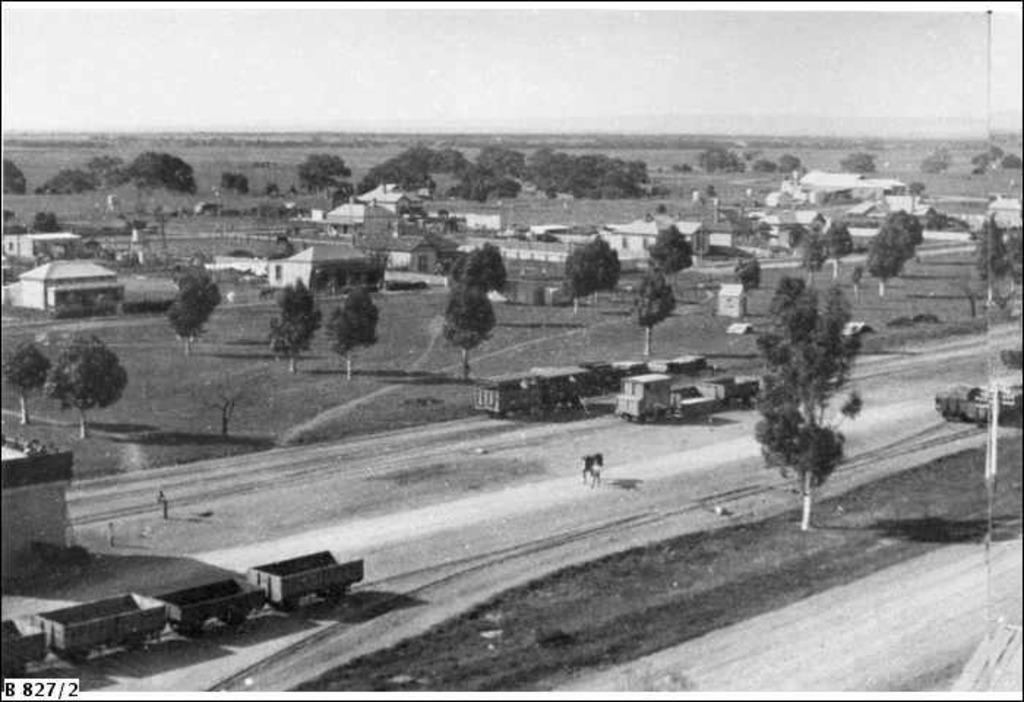What type of natural elements can be seen in the image? There are many trees in the image. What type of man-made structures are present in the image? There are houses in the image. What type of transportation is visible in the image? There are vehicles in the image. What is the pathway for the vehicles in the image? There is a road in the image. What is visible at the top of the image? The sky is visible at the top of the image. What type of button can be seen on the stomach of the person in the image? There is no person present in the image, and therefore no button or stomach can be observed. What color is the underwear of the person in the image? There is no person present in the image, and therefore no underwear can be observed. 